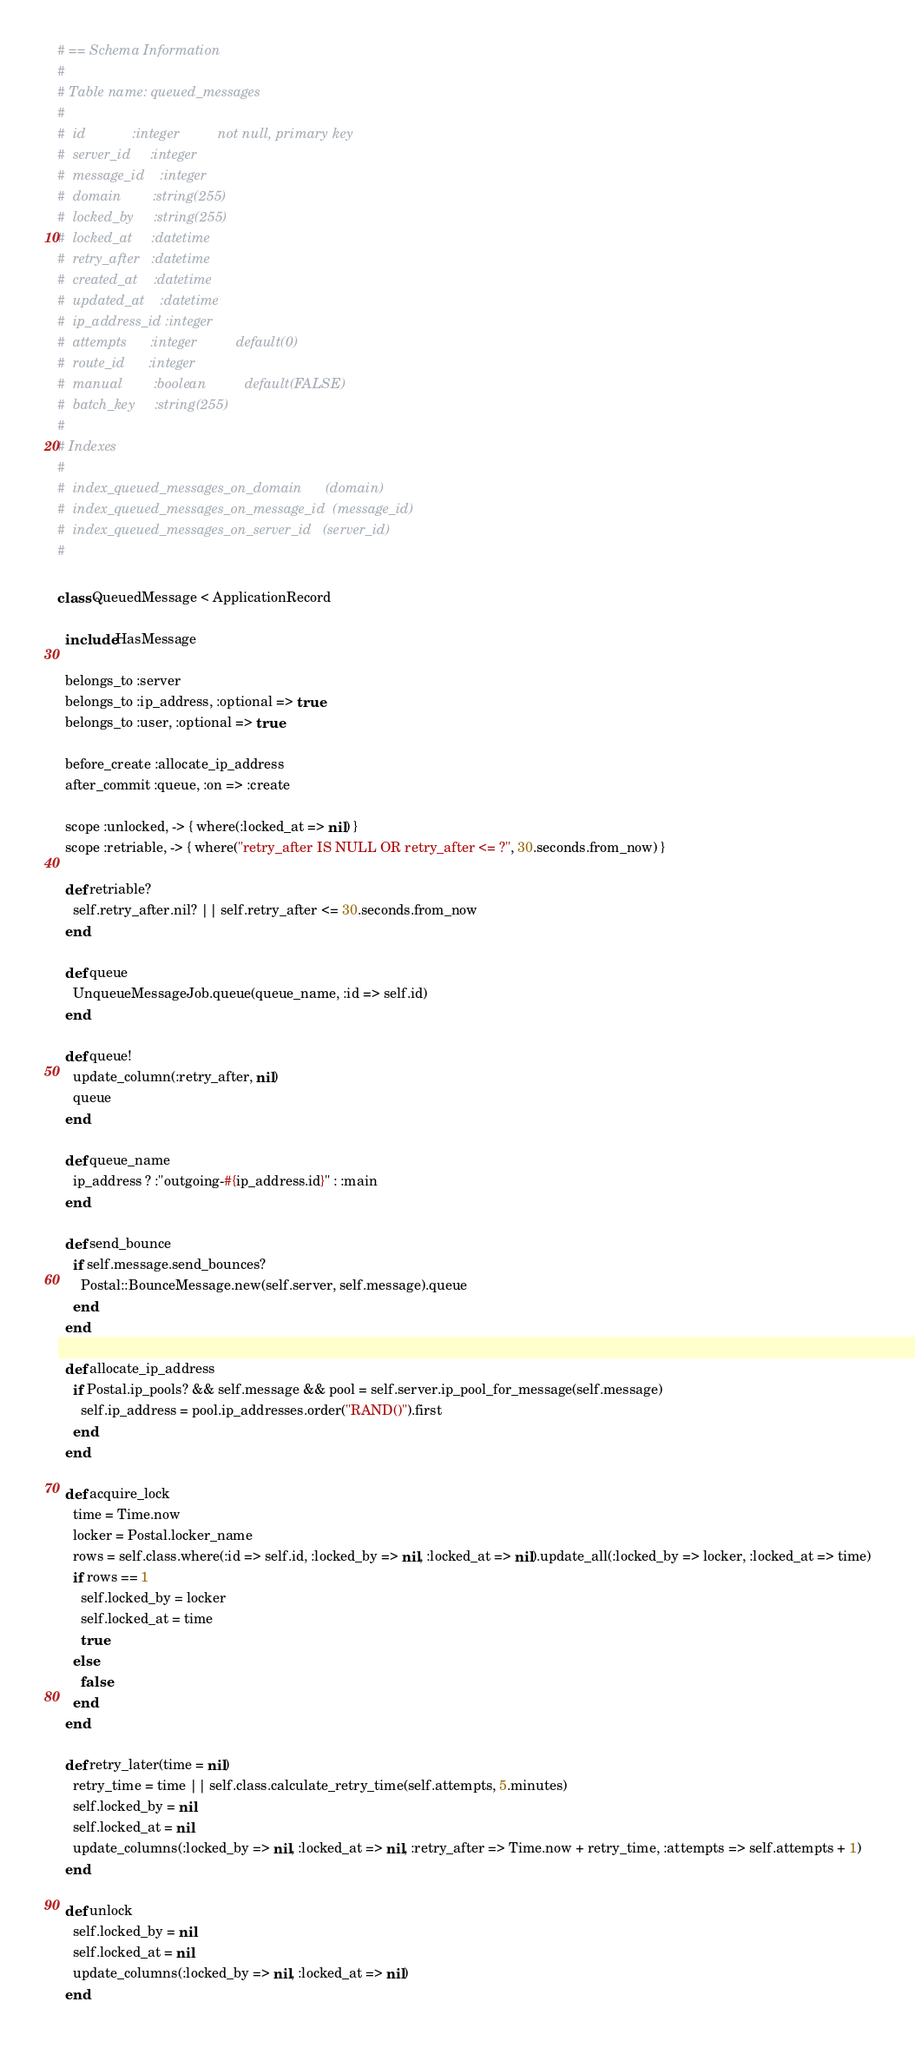<code> <loc_0><loc_0><loc_500><loc_500><_Ruby_># == Schema Information
#
# Table name: queued_messages
#
#  id            :integer          not null, primary key
#  server_id     :integer
#  message_id    :integer
#  domain        :string(255)
#  locked_by     :string(255)
#  locked_at     :datetime
#  retry_after   :datetime
#  created_at    :datetime
#  updated_at    :datetime
#  ip_address_id :integer
#  attempts      :integer          default(0)
#  route_id      :integer
#  manual        :boolean          default(FALSE)
#  batch_key     :string(255)
#
# Indexes
#
#  index_queued_messages_on_domain      (domain)
#  index_queued_messages_on_message_id  (message_id)
#  index_queued_messages_on_server_id   (server_id)
#

class QueuedMessage < ApplicationRecord

  include HasMessage

  belongs_to :server
  belongs_to :ip_address, :optional => true
  belongs_to :user, :optional => true

  before_create :allocate_ip_address
  after_commit :queue, :on => :create

  scope :unlocked, -> { where(:locked_at => nil) }
  scope :retriable, -> { where("retry_after IS NULL OR retry_after <= ?", 30.seconds.from_now) }

  def retriable?
    self.retry_after.nil? || self.retry_after <= 30.seconds.from_now
  end

  def queue
    UnqueueMessageJob.queue(queue_name, :id => self.id)
  end

  def queue!
    update_column(:retry_after, nil)
    queue
  end

  def queue_name
    ip_address ? :"outgoing-#{ip_address.id}" : :main
  end

  def send_bounce
    if self.message.send_bounces?
      Postal::BounceMessage.new(self.server, self.message).queue
    end
  end

  def allocate_ip_address
    if Postal.ip_pools? && self.message && pool = self.server.ip_pool_for_message(self.message)
      self.ip_address = pool.ip_addresses.order("RAND()").first
    end
  end

  def acquire_lock
    time = Time.now
    locker = Postal.locker_name
    rows = self.class.where(:id => self.id, :locked_by => nil, :locked_at => nil).update_all(:locked_by => locker, :locked_at => time)
    if rows == 1
      self.locked_by = locker
      self.locked_at = time
      true
    else
      false
    end
  end

  def retry_later(time = nil)
    retry_time = time || self.class.calculate_retry_time(self.attempts, 5.minutes)
    self.locked_by = nil
    self.locked_at = nil
    update_columns(:locked_by => nil, :locked_at => nil, :retry_after => Time.now + retry_time, :attempts => self.attempts + 1)
  end

  def unlock
    self.locked_by = nil
    self.locked_at = nil
    update_columns(:locked_by => nil, :locked_at => nil)
  end
</code> 